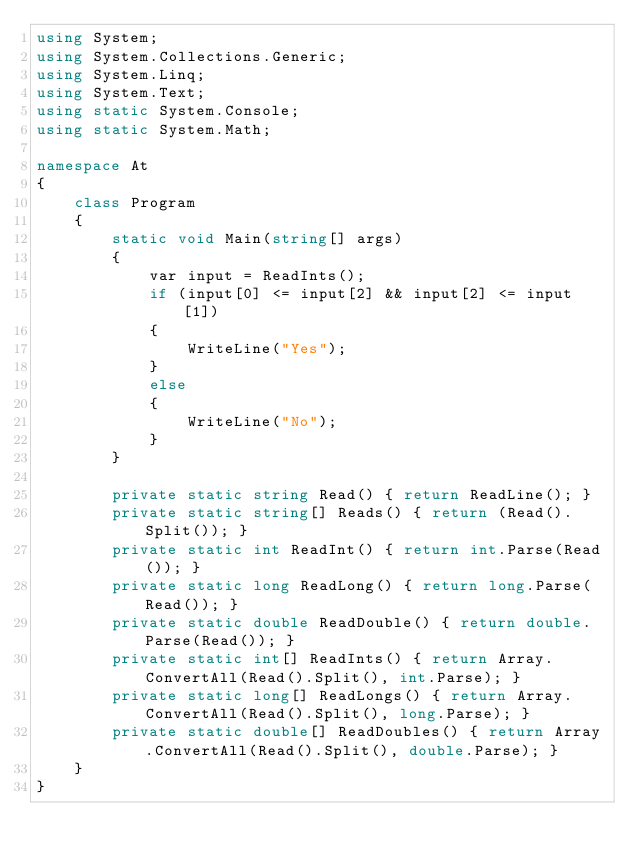<code> <loc_0><loc_0><loc_500><loc_500><_C#_>using System;
using System.Collections.Generic;
using System.Linq;
using System.Text;
using static System.Console;
using static System.Math;

namespace At
{
    class Program
    {
        static void Main(string[] args)
        {
            var input = ReadInts();
            if (input[0] <= input[2] && input[2] <= input[1])
            {
                WriteLine("Yes");
            }
            else
            {
                WriteLine("No");
            }
        }

        private static string Read() { return ReadLine(); }
        private static string[] Reads() { return (Read().Split()); }
        private static int ReadInt() { return int.Parse(Read()); }
        private static long ReadLong() { return long.Parse(Read()); }
        private static double ReadDouble() { return double.Parse(Read()); }
        private static int[] ReadInts() { return Array.ConvertAll(Read().Split(), int.Parse); }
        private static long[] ReadLongs() { return Array.ConvertAll(Read().Split(), long.Parse); }
        private static double[] ReadDoubles() { return Array.ConvertAll(Read().Split(), double.Parse); }
    }
}
</code> 